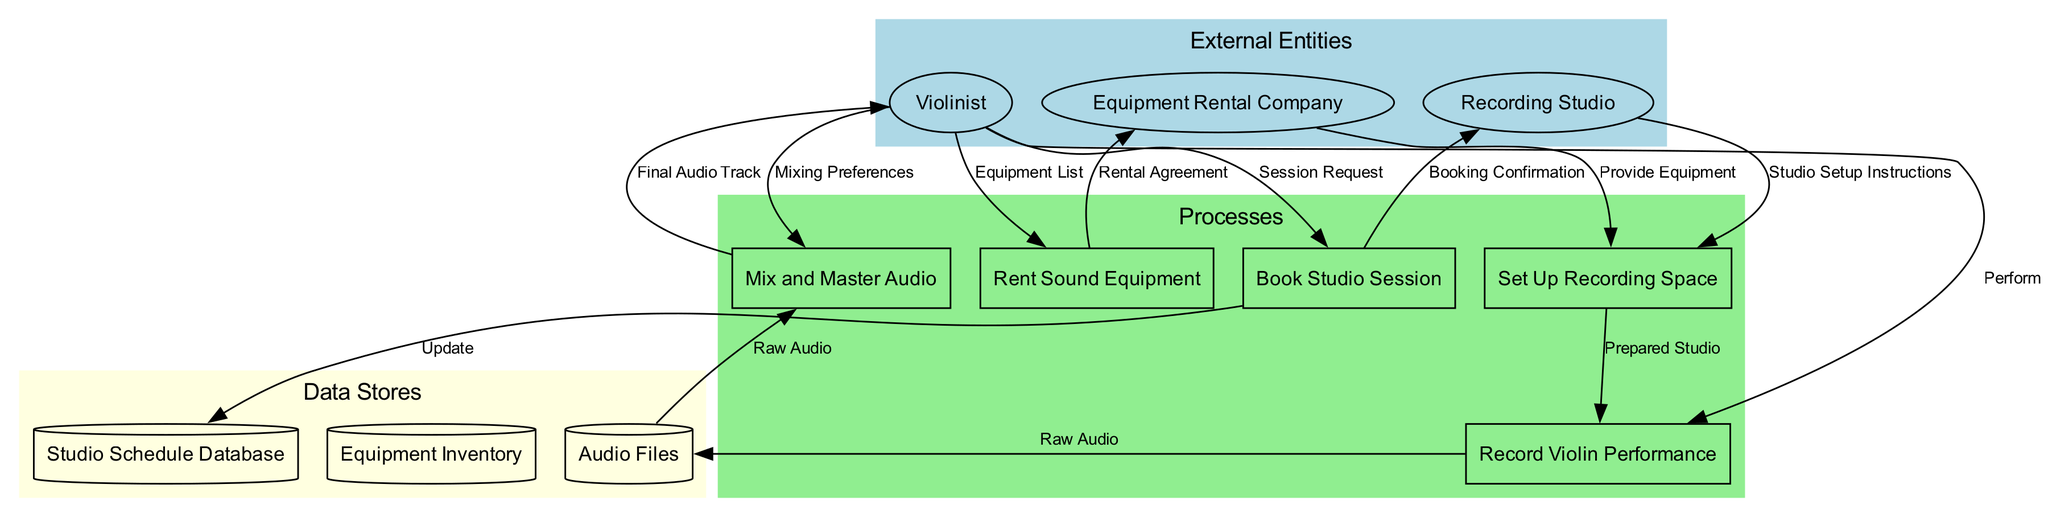What are the external entities in the diagram? The diagram identifies three external entities: Violinist, Recording Studio, and Equipment Rental Company. These are shown as elliptical nodes in the external entities section of the diagram.
Answer: Violinist, Recording Studio, Equipment Rental Company How many processes are represented in the diagram? The diagram features five processes: Book Studio Session, Rent Sound Equipment, Set Up Recording Space, Record Violin Performance, and Mix and Master Audio. By counting the rectangular nodes in the processes section, we confirm there are five.
Answer: 5 What is the data flow from the Violinist to the Book Studio Session? The data flow from the Violinist to the Book Studio Session is labeled "Session Request," which indicates the type of information or action that occurs in that flow. This is represented by an edge from the Violinist to the process node.
Answer: Session Request Which process is responsible for updating the Studio Schedule Database? The process responsible for updating the Studio Schedule Database is "Book Studio Session." This is shown where an edge connects the process to the data store indicating an update takes place at that step.
Answer: Book Studio Session What data flow is associated with the Rental Agreement? The data flow associated with the Rental Agreement is labeled "Rental Agreement," which flows from the Rent Sound Equipment process to the Equipment Rental Company. This is indicated by the edge linking these two entities.
Answer: Rental Agreement Which process utilizes raw audio files? The process that utilizes raw audio files is "Mix and Master Audio." This is shown by the edge that connects the Audio Files data store directly to the Mix and Master Audio process, indicating that raw audio is input here.
Answer: Mix and Master Audio What is the final output of the audio process? The final output of the audio process is the "Final Audio Track," which is sent back to the Violinist from the Mix and Master Audio process. This is indicated by the edge flowing to the Violinist node showing the result of this process.
Answer: Final Audio Track How does the Equipment Rental Company relate to the Setup process? The Equipment Rental Company relates to the Setup process by providing equipment, as shown by the edge that connects the Equipment Rental Company to the Set Up Recording Space process, indicating an essential action in this flow.
Answer: Provide Equipment What type of data store contains audio files? The type of data store that contains audio files is termed "Audio Files," represented as a cylinder in the diagram. This data store receives data from the Record Violin Performance process and is utilized in the Mix and Master Audio process.
Answer: Audio Files 